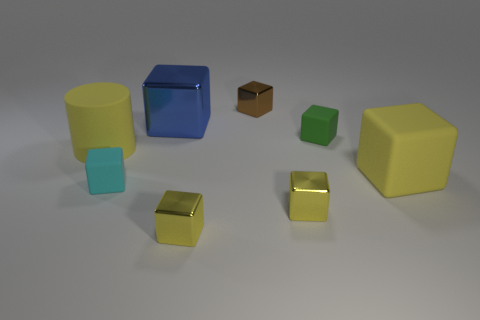Add 1 big green cylinders. How many objects exist? 9 Subtract all tiny green matte cubes. How many cubes are left? 6 Subtract all yellow blocks. How many blocks are left? 4 Subtract all gray cylinders. Subtract all purple blocks. How many cylinders are left? 1 Subtract all blue cylinders. How many blue blocks are left? 1 Subtract all yellow matte cubes. Subtract all tiny blocks. How many objects are left? 2 Add 1 tiny shiny objects. How many tiny shiny objects are left? 4 Add 6 small brown metal cylinders. How many small brown metal cylinders exist? 6 Subtract 0 gray blocks. How many objects are left? 8 Subtract all cubes. How many objects are left? 1 